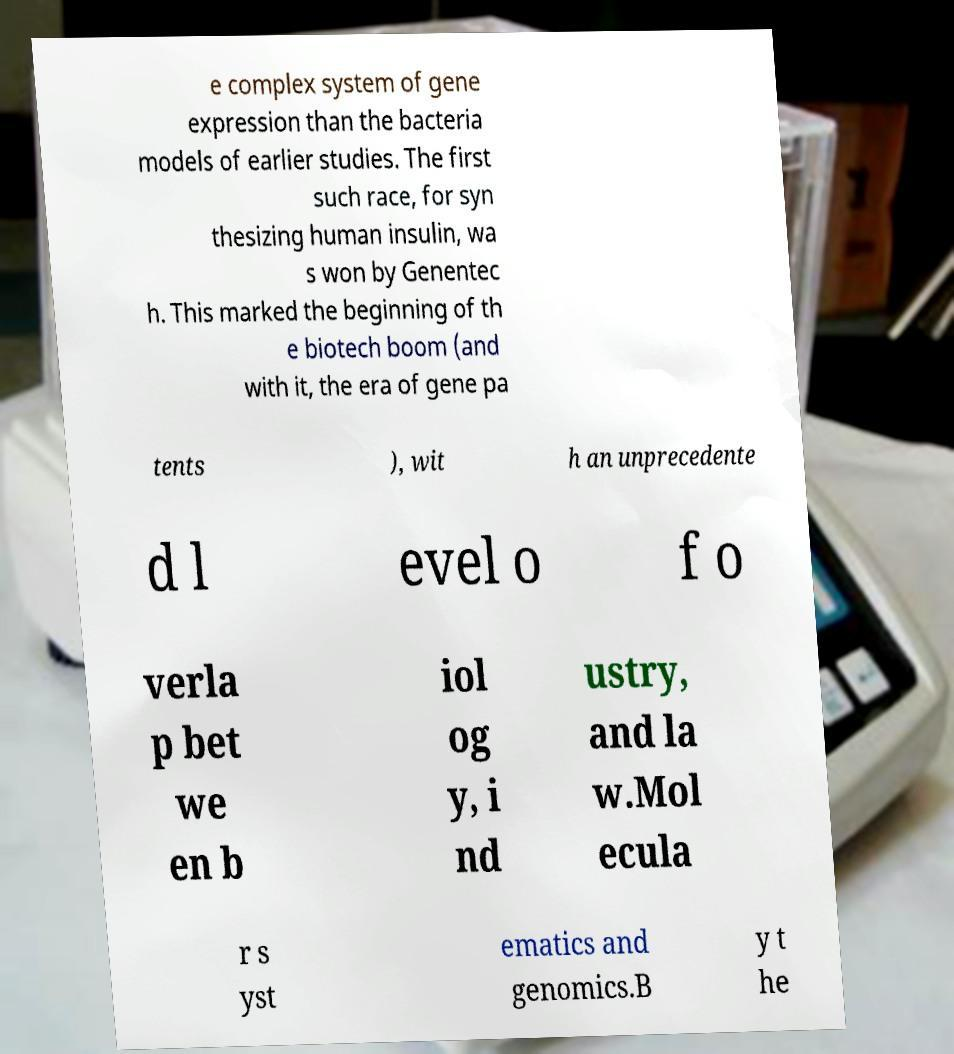I need the written content from this picture converted into text. Can you do that? e complex system of gene expression than the bacteria models of earlier studies. The first such race, for syn thesizing human insulin, wa s won by Genentec h. This marked the beginning of th e biotech boom (and with it, the era of gene pa tents ), wit h an unprecedente d l evel o f o verla p bet we en b iol og y, i nd ustry, and la w.Mol ecula r s yst ematics and genomics.B y t he 